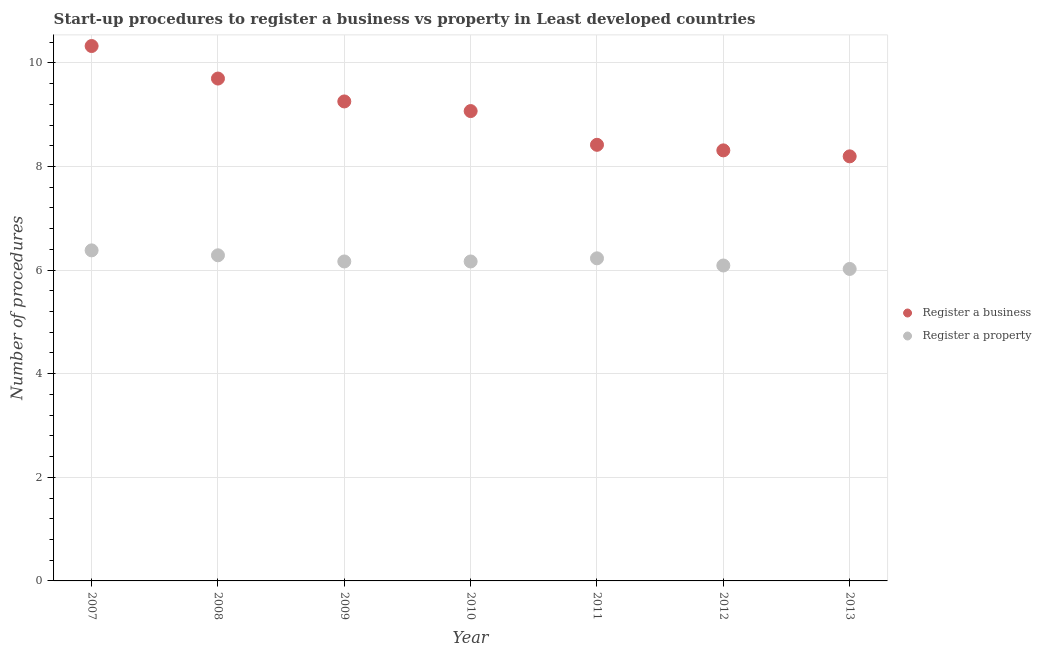Is the number of dotlines equal to the number of legend labels?
Your response must be concise. Yes. What is the number of procedures to register a business in 2012?
Offer a very short reply. 8.31. Across all years, what is the maximum number of procedures to register a property?
Offer a very short reply. 6.38. Across all years, what is the minimum number of procedures to register a business?
Your response must be concise. 8.2. In which year was the number of procedures to register a business minimum?
Offer a terse response. 2013. What is the total number of procedures to register a property in the graph?
Your response must be concise. 43.34. What is the difference between the number of procedures to register a business in 2007 and that in 2013?
Keep it short and to the point. 2.13. What is the difference between the number of procedures to register a business in 2010 and the number of procedures to register a property in 2008?
Provide a succinct answer. 2.78. What is the average number of procedures to register a property per year?
Your answer should be compact. 6.19. In the year 2013, what is the difference between the number of procedures to register a property and number of procedures to register a business?
Your answer should be compact. -2.17. What is the ratio of the number of procedures to register a business in 2007 to that in 2008?
Your answer should be compact. 1.06. What is the difference between the highest and the second highest number of procedures to register a business?
Offer a terse response. 0.63. What is the difference between the highest and the lowest number of procedures to register a property?
Provide a short and direct response. 0.36. In how many years, is the number of procedures to register a property greater than the average number of procedures to register a property taken over all years?
Make the answer very short. 3. Is the sum of the number of procedures to register a property in 2008 and 2013 greater than the maximum number of procedures to register a business across all years?
Keep it short and to the point. Yes. Does the number of procedures to register a business monotonically increase over the years?
Make the answer very short. No. Is the number of procedures to register a property strictly less than the number of procedures to register a business over the years?
Ensure brevity in your answer.  Yes. Where does the legend appear in the graph?
Your response must be concise. Center right. What is the title of the graph?
Make the answer very short. Start-up procedures to register a business vs property in Least developed countries. Does "Automatic Teller Machines" appear as one of the legend labels in the graph?
Your answer should be very brief. No. What is the label or title of the X-axis?
Your answer should be very brief. Year. What is the label or title of the Y-axis?
Your answer should be compact. Number of procedures. What is the Number of procedures of Register a business in 2007?
Offer a very short reply. 10.33. What is the Number of procedures in Register a property in 2007?
Keep it short and to the point. 6.38. What is the Number of procedures in Register a business in 2008?
Your response must be concise. 9.7. What is the Number of procedures of Register a property in 2008?
Offer a very short reply. 6.29. What is the Number of procedures of Register a business in 2009?
Provide a succinct answer. 9.26. What is the Number of procedures of Register a property in 2009?
Keep it short and to the point. 6.17. What is the Number of procedures in Register a business in 2010?
Make the answer very short. 9.07. What is the Number of procedures in Register a property in 2010?
Offer a terse response. 6.17. What is the Number of procedures in Register a business in 2011?
Offer a very short reply. 8.42. What is the Number of procedures of Register a property in 2011?
Your response must be concise. 6.23. What is the Number of procedures in Register a business in 2012?
Your response must be concise. 8.31. What is the Number of procedures in Register a property in 2012?
Offer a very short reply. 6.09. What is the Number of procedures in Register a business in 2013?
Make the answer very short. 8.2. What is the Number of procedures in Register a property in 2013?
Keep it short and to the point. 6.02. Across all years, what is the maximum Number of procedures in Register a business?
Keep it short and to the point. 10.33. Across all years, what is the maximum Number of procedures of Register a property?
Keep it short and to the point. 6.38. Across all years, what is the minimum Number of procedures of Register a business?
Your answer should be very brief. 8.2. Across all years, what is the minimum Number of procedures in Register a property?
Your answer should be compact. 6.02. What is the total Number of procedures in Register a business in the graph?
Your answer should be very brief. 63.27. What is the total Number of procedures of Register a property in the graph?
Keep it short and to the point. 43.34. What is the difference between the Number of procedures in Register a business in 2007 and that in 2008?
Your answer should be compact. 0.63. What is the difference between the Number of procedures in Register a property in 2007 and that in 2008?
Ensure brevity in your answer.  0.1. What is the difference between the Number of procedures in Register a business in 2007 and that in 2009?
Keep it short and to the point. 1.07. What is the difference between the Number of procedures of Register a property in 2007 and that in 2009?
Your response must be concise. 0.21. What is the difference between the Number of procedures of Register a business in 2007 and that in 2010?
Your answer should be very brief. 1.26. What is the difference between the Number of procedures in Register a property in 2007 and that in 2010?
Give a very brief answer. 0.21. What is the difference between the Number of procedures of Register a business in 2007 and that in 2011?
Provide a succinct answer. 1.91. What is the difference between the Number of procedures in Register a property in 2007 and that in 2011?
Your response must be concise. 0.15. What is the difference between the Number of procedures of Register a business in 2007 and that in 2012?
Offer a terse response. 2.01. What is the difference between the Number of procedures of Register a property in 2007 and that in 2012?
Provide a succinct answer. 0.29. What is the difference between the Number of procedures in Register a business in 2007 and that in 2013?
Offer a terse response. 2.13. What is the difference between the Number of procedures of Register a property in 2007 and that in 2013?
Keep it short and to the point. 0.36. What is the difference between the Number of procedures in Register a business in 2008 and that in 2009?
Ensure brevity in your answer.  0.44. What is the difference between the Number of procedures in Register a property in 2008 and that in 2009?
Ensure brevity in your answer.  0.12. What is the difference between the Number of procedures in Register a business in 2008 and that in 2010?
Keep it short and to the point. 0.63. What is the difference between the Number of procedures in Register a property in 2008 and that in 2010?
Your answer should be compact. 0.12. What is the difference between the Number of procedures in Register a business in 2008 and that in 2011?
Your answer should be compact. 1.28. What is the difference between the Number of procedures in Register a property in 2008 and that in 2011?
Your response must be concise. 0.06. What is the difference between the Number of procedures of Register a business in 2008 and that in 2012?
Offer a very short reply. 1.39. What is the difference between the Number of procedures of Register a property in 2008 and that in 2012?
Offer a terse response. 0.2. What is the difference between the Number of procedures of Register a business in 2008 and that in 2013?
Ensure brevity in your answer.  1.5. What is the difference between the Number of procedures of Register a property in 2008 and that in 2013?
Offer a terse response. 0.26. What is the difference between the Number of procedures in Register a business in 2009 and that in 2010?
Offer a terse response. 0.19. What is the difference between the Number of procedures in Register a property in 2009 and that in 2010?
Ensure brevity in your answer.  0. What is the difference between the Number of procedures of Register a business in 2009 and that in 2011?
Your answer should be very brief. 0.84. What is the difference between the Number of procedures of Register a property in 2009 and that in 2011?
Your answer should be very brief. -0.06. What is the difference between the Number of procedures of Register a business in 2009 and that in 2012?
Your answer should be very brief. 0.94. What is the difference between the Number of procedures of Register a property in 2009 and that in 2012?
Offer a very short reply. 0.08. What is the difference between the Number of procedures in Register a business in 2009 and that in 2013?
Offer a very short reply. 1.06. What is the difference between the Number of procedures in Register a property in 2009 and that in 2013?
Keep it short and to the point. 0.14. What is the difference between the Number of procedures of Register a business in 2010 and that in 2011?
Make the answer very short. 0.65. What is the difference between the Number of procedures in Register a property in 2010 and that in 2011?
Offer a very short reply. -0.06. What is the difference between the Number of procedures in Register a business in 2010 and that in 2012?
Offer a terse response. 0.76. What is the difference between the Number of procedures of Register a property in 2010 and that in 2012?
Offer a very short reply. 0.08. What is the difference between the Number of procedures in Register a business in 2010 and that in 2013?
Your answer should be very brief. 0.87. What is the difference between the Number of procedures in Register a property in 2010 and that in 2013?
Your answer should be very brief. 0.14. What is the difference between the Number of procedures in Register a business in 2011 and that in 2012?
Give a very brief answer. 0.11. What is the difference between the Number of procedures of Register a property in 2011 and that in 2012?
Provide a short and direct response. 0.14. What is the difference between the Number of procedures of Register a business in 2011 and that in 2013?
Ensure brevity in your answer.  0.22. What is the difference between the Number of procedures in Register a property in 2011 and that in 2013?
Your answer should be very brief. 0.21. What is the difference between the Number of procedures of Register a business in 2012 and that in 2013?
Your response must be concise. 0.12. What is the difference between the Number of procedures in Register a property in 2012 and that in 2013?
Make the answer very short. 0.07. What is the difference between the Number of procedures in Register a business in 2007 and the Number of procedures in Register a property in 2008?
Offer a terse response. 4.04. What is the difference between the Number of procedures in Register a business in 2007 and the Number of procedures in Register a property in 2009?
Provide a succinct answer. 4.16. What is the difference between the Number of procedures in Register a business in 2007 and the Number of procedures in Register a property in 2010?
Your answer should be very brief. 4.16. What is the difference between the Number of procedures in Register a business in 2007 and the Number of procedures in Register a property in 2011?
Provide a succinct answer. 4.1. What is the difference between the Number of procedures in Register a business in 2007 and the Number of procedures in Register a property in 2012?
Keep it short and to the point. 4.24. What is the difference between the Number of procedures in Register a business in 2007 and the Number of procedures in Register a property in 2013?
Keep it short and to the point. 4.3. What is the difference between the Number of procedures of Register a business in 2008 and the Number of procedures of Register a property in 2009?
Provide a short and direct response. 3.53. What is the difference between the Number of procedures in Register a business in 2008 and the Number of procedures in Register a property in 2010?
Your answer should be very brief. 3.53. What is the difference between the Number of procedures of Register a business in 2008 and the Number of procedures of Register a property in 2011?
Provide a short and direct response. 3.47. What is the difference between the Number of procedures in Register a business in 2008 and the Number of procedures in Register a property in 2012?
Your answer should be compact. 3.61. What is the difference between the Number of procedures of Register a business in 2008 and the Number of procedures of Register a property in 2013?
Your answer should be compact. 3.68. What is the difference between the Number of procedures of Register a business in 2009 and the Number of procedures of Register a property in 2010?
Your answer should be very brief. 3.09. What is the difference between the Number of procedures in Register a business in 2009 and the Number of procedures in Register a property in 2011?
Your answer should be compact. 3.03. What is the difference between the Number of procedures of Register a business in 2009 and the Number of procedures of Register a property in 2012?
Your answer should be compact. 3.17. What is the difference between the Number of procedures of Register a business in 2009 and the Number of procedures of Register a property in 2013?
Your answer should be very brief. 3.23. What is the difference between the Number of procedures of Register a business in 2010 and the Number of procedures of Register a property in 2011?
Make the answer very short. 2.84. What is the difference between the Number of procedures of Register a business in 2010 and the Number of procedures of Register a property in 2012?
Your response must be concise. 2.98. What is the difference between the Number of procedures in Register a business in 2010 and the Number of procedures in Register a property in 2013?
Your response must be concise. 3.05. What is the difference between the Number of procedures in Register a business in 2011 and the Number of procedures in Register a property in 2012?
Make the answer very short. 2.33. What is the difference between the Number of procedures of Register a business in 2011 and the Number of procedures of Register a property in 2013?
Provide a short and direct response. 2.4. What is the difference between the Number of procedures of Register a business in 2012 and the Number of procedures of Register a property in 2013?
Provide a short and direct response. 2.29. What is the average Number of procedures in Register a business per year?
Offer a terse response. 9.04. What is the average Number of procedures of Register a property per year?
Give a very brief answer. 6.19. In the year 2007, what is the difference between the Number of procedures in Register a business and Number of procedures in Register a property?
Offer a terse response. 3.94. In the year 2008, what is the difference between the Number of procedures of Register a business and Number of procedures of Register a property?
Your answer should be compact. 3.41. In the year 2009, what is the difference between the Number of procedures in Register a business and Number of procedures in Register a property?
Provide a succinct answer. 3.09. In the year 2010, what is the difference between the Number of procedures of Register a business and Number of procedures of Register a property?
Make the answer very short. 2.9. In the year 2011, what is the difference between the Number of procedures in Register a business and Number of procedures in Register a property?
Give a very brief answer. 2.19. In the year 2012, what is the difference between the Number of procedures of Register a business and Number of procedures of Register a property?
Keep it short and to the point. 2.22. In the year 2013, what is the difference between the Number of procedures in Register a business and Number of procedures in Register a property?
Offer a terse response. 2.17. What is the ratio of the Number of procedures in Register a business in 2007 to that in 2008?
Your answer should be very brief. 1.06. What is the ratio of the Number of procedures in Register a property in 2007 to that in 2008?
Provide a short and direct response. 1.02. What is the ratio of the Number of procedures in Register a business in 2007 to that in 2009?
Provide a succinct answer. 1.12. What is the ratio of the Number of procedures in Register a property in 2007 to that in 2009?
Keep it short and to the point. 1.03. What is the ratio of the Number of procedures in Register a business in 2007 to that in 2010?
Make the answer very short. 1.14. What is the ratio of the Number of procedures in Register a property in 2007 to that in 2010?
Your answer should be compact. 1.03. What is the ratio of the Number of procedures of Register a business in 2007 to that in 2011?
Your response must be concise. 1.23. What is the ratio of the Number of procedures in Register a property in 2007 to that in 2011?
Offer a terse response. 1.02. What is the ratio of the Number of procedures in Register a business in 2007 to that in 2012?
Your answer should be compact. 1.24. What is the ratio of the Number of procedures in Register a property in 2007 to that in 2012?
Provide a short and direct response. 1.05. What is the ratio of the Number of procedures in Register a business in 2007 to that in 2013?
Offer a terse response. 1.26. What is the ratio of the Number of procedures of Register a property in 2007 to that in 2013?
Give a very brief answer. 1.06. What is the ratio of the Number of procedures in Register a business in 2008 to that in 2009?
Keep it short and to the point. 1.05. What is the ratio of the Number of procedures in Register a property in 2008 to that in 2009?
Make the answer very short. 1.02. What is the ratio of the Number of procedures in Register a business in 2008 to that in 2010?
Offer a very short reply. 1.07. What is the ratio of the Number of procedures in Register a property in 2008 to that in 2010?
Ensure brevity in your answer.  1.02. What is the ratio of the Number of procedures in Register a business in 2008 to that in 2011?
Provide a succinct answer. 1.15. What is the ratio of the Number of procedures in Register a property in 2008 to that in 2011?
Give a very brief answer. 1.01. What is the ratio of the Number of procedures of Register a business in 2008 to that in 2012?
Offer a terse response. 1.17. What is the ratio of the Number of procedures in Register a property in 2008 to that in 2012?
Your answer should be compact. 1.03. What is the ratio of the Number of procedures in Register a business in 2008 to that in 2013?
Offer a very short reply. 1.18. What is the ratio of the Number of procedures of Register a property in 2008 to that in 2013?
Provide a short and direct response. 1.04. What is the ratio of the Number of procedures of Register a business in 2009 to that in 2010?
Your answer should be very brief. 1.02. What is the ratio of the Number of procedures in Register a property in 2009 to that in 2010?
Offer a very short reply. 1. What is the ratio of the Number of procedures of Register a business in 2009 to that in 2011?
Your response must be concise. 1.1. What is the ratio of the Number of procedures in Register a property in 2009 to that in 2011?
Give a very brief answer. 0.99. What is the ratio of the Number of procedures in Register a business in 2009 to that in 2012?
Give a very brief answer. 1.11. What is the ratio of the Number of procedures in Register a property in 2009 to that in 2012?
Ensure brevity in your answer.  1.01. What is the ratio of the Number of procedures of Register a business in 2009 to that in 2013?
Make the answer very short. 1.13. What is the ratio of the Number of procedures of Register a business in 2010 to that in 2011?
Provide a succinct answer. 1.08. What is the ratio of the Number of procedures of Register a property in 2010 to that in 2011?
Keep it short and to the point. 0.99. What is the ratio of the Number of procedures of Register a business in 2010 to that in 2012?
Keep it short and to the point. 1.09. What is the ratio of the Number of procedures of Register a property in 2010 to that in 2012?
Your response must be concise. 1.01. What is the ratio of the Number of procedures in Register a business in 2010 to that in 2013?
Your response must be concise. 1.11. What is the ratio of the Number of procedures in Register a property in 2010 to that in 2013?
Provide a succinct answer. 1.02. What is the ratio of the Number of procedures of Register a business in 2011 to that in 2012?
Your answer should be compact. 1.01. What is the ratio of the Number of procedures in Register a property in 2011 to that in 2012?
Keep it short and to the point. 1.02. What is the ratio of the Number of procedures of Register a business in 2011 to that in 2013?
Make the answer very short. 1.03. What is the ratio of the Number of procedures in Register a property in 2011 to that in 2013?
Provide a short and direct response. 1.03. What is the ratio of the Number of procedures of Register a business in 2012 to that in 2013?
Keep it short and to the point. 1.01. What is the ratio of the Number of procedures in Register a property in 2012 to that in 2013?
Your answer should be very brief. 1.01. What is the difference between the highest and the second highest Number of procedures in Register a business?
Your answer should be compact. 0.63. What is the difference between the highest and the second highest Number of procedures in Register a property?
Offer a very short reply. 0.1. What is the difference between the highest and the lowest Number of procedures in Register a business?
Your answer should be compact. 2.13. What is the difference between the highest and the lowest Number of procedures in Register a property?
Your answer should be very brief. 0.36. 